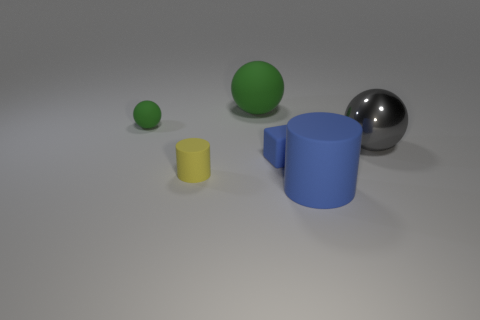What could be the function of these objects in real-life applications? In real-life applications, these objects could serve various purposes. The yellow and blue cylinders might be used as containers or as parts of machinery, whereas the spheres could be used as balls in different sports or as part of a ball-valve mechanism in plumbing systems. The varying sizes also suggest that they could be educational tools for teaching geometry or proportions. 